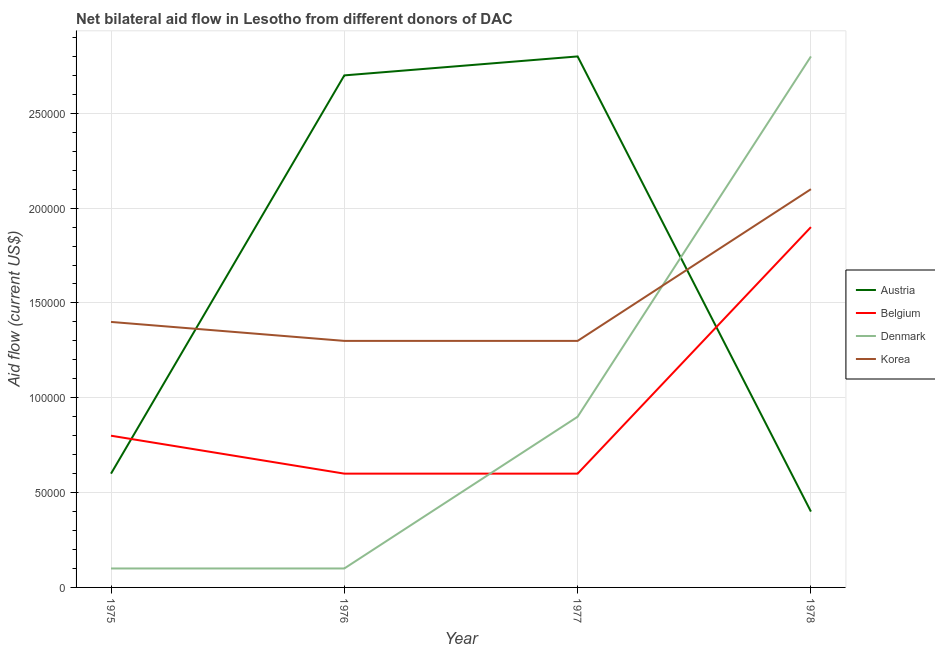How many different coloured lines are there?
Your answer should be very brief. 4. Is the number of lines equal to the number of legend labels?
Your answer should be compact. Yes. What is the amount of aid given by austria in 1975?
Provide a short and direct response. 6.00e+04. Across all years, what is the maximum amount of aid given by belgium?
Your answer should be compact. 1.90e+05. Across all years, what is the minimum amount of aid given by austria?
Provide a succinct answer. 4.00e+04. In which year was the amount of aid given by austria maximum?
Offer a very short reply. 1977. In which year was the amount of aid given by denmark minimum?
Make the answer very short. 1975. What is the total amount of aid given by austria in the graph?
Ensure brevity in your answer.  6.50e+05. What is the difference between the amount of aid given by korea in 1975 and that in 1978?
Your answer should be very brief. -7.00e+04. What is the difference between the amount of aid given by belgium in 1977 and the amount of aid given by denmark in 1976?
Provide a short and direct response. 5.00e+04. What is the average amount of aid given by korea per year?
Offer a terse response. 1.52e+05. In the year 1978, what is the difference between the amount of aid given by denmark and amount of aid given by belgium?
Make the answer very short. 9.00e+04. In how many years, is the amount of aid given by korea greater than 280000 US$?
Make the answer very short. 0. What is the ratio of the amount of aid given by korea in 1975 to that in 1976?
Your answer should be compact. 1.08. Is the amount of aid given by austria in 1976 less than that in 1977?
Provide a short and direct response. Yes. Is the difference between the amount of aid given by belgium in 1975 and 1976 greater than the difference between the amount of aid given by korea in 1975 and 1976?
Your answer should be very brief. Yes. What is the difference between the highest and the lowest amount of aid given by belgium?
Provide a succinct answer. 1.30e+05. In how many years, is the amount of aid given by denmark greater than the average amount of aid given by denmark taken over all years?
Your answer should be compact. 1. Is it the case that in every year, the sum of the amount of aid given by denmark and amount of aid given by austria is greater than the sum of amount of aid given by korea and amount of aid given by belgium?
Give a very brief answer. No. Is it the case that in every year, the sum of the amount of aid given by austria and amount of aid given by belgium is greater than the amount of aid given by denmark?
Your response must be concise. No. Does the amount of aid given by denmark monotonically increase over the years?
Provide a succinct answer. No. Is the amount of aid given by austria strictly less than the amount of aid given by korea over the years?
Make the answer very short. No. How many lines are there?
Give a very brief answer. 4. What is the difference between two consecutive major ticks on the Y-axis?
Your answer should be very brief. 5.00e+04. Does the graph contain any zero values?
Your response must be concise. No. Does the graph contain grids?
Ensure brevity in your answer.  Yes. How many legend labels are there?
Provide a short and direct response. 4. What is the title of the graph?
Your answer should be compact. Net bilateral aid flow in Lesotho from different donors of DAC. Does "Other Minerals" appear as one of the legend labels in the graph?
Your answer should be very brief. No. What is the label or title of the Y-axis?
Give a very brief answer. Aid flow (current US$). What is the Aid flow (current US$) of Denmark in 1975?
Your answer should be compact. 10000. What is the Aid flow (current US$) in Korea in 1976?
Provide a succinct answer. 1.30e+05. What is the Aid flow (current US$) in Austria in 1977?
Provide a short and direct response. 2.80e+05. What is the Aid flow (current US$) in Belgium in 1977?
Keep it short and to the point. 6.00e+04. What is the Aid flow (current US$) in Denmark in 1978?
Offer a very short reply. 2.80e+05. Across all years, what is the maximum Aid flow (current US$) in Korea?
Make the answer very short. 2.10e+05. Across all years, what is the minimum Aid flow (current US$) of Austria?
Offer a very short reply. 4.00e+04. Across all years, what is the minimum Aid flow (current US$) of Denmark?
Give a very brief answer. 10000. What is the total Aid flow (current US$) in Austria in the graph?
Your response must be concise. 6.50e+05. What is the total Aid flow (current US$) of Denmark in the graph?
Offer a terse response. 3.90e+05. What is the total Aid flow (current US$) of Korea in the graph?
Your answer should be very brief. 6.10e+05. What is the difference between the Aid flow (current US$) in Austria in 1975 and that in 1976?
Provide a short and direct response. -2.10e+05. What is the difference between the Aid flow (current US$) of Denmark in 1975 and that in 1976?
Your response must be concise. 0. What is the difference between the Aid flow (current US$) in Korea in 1975 and that in 1977?
Offer a terse response. 10000. What is the difference between the Aid flow (current US$) in Korea in 1975 and that in 1978?
Your answer should be compact. -7.00e+04. What is the difference between the Aid flow (current US$) of Austria in 1976 and that in 1977?
Offer a terse response. -10000. What is the difference between the Aid flow (current US$) in Korea in 1976 and that in 1977?
Your response must be concise. 0. What is the difference between the Aid flow (current US$) in Denmark in 1976 and that in 1978?
Your response must be concise. -2.70e+05. What is the difference between the Aid flow (current US$) in Korea in 1976 and that in 1978?
Ensure brevity in your answer.  -8.00e+04. What is the difference between the Aid flow (current US$) in Belgium in 1977 and that in 1978?
Ensure brevity in your answer.  -1.30e+05. What is the difference between the Aid flow (current US$) in Austria in 1975 and the Aid flow (current US$) in Korea in 1976?
Your answer should be compact. -7.00e+04. What is the difference between the Aid flow (current US$) in Belgium in 1975 and the Aid flow (current US$) in Denmark in 1976?
Give a very brief answer. 7.00e+04. What is the difference between the Aid flow (current US$) of Belgium in 1975 and the Aid flow (current US$) of Korea in 1976?
Give a very brief answer. -5.00e+04. What is the difference between the Aid flow (current US$) in Belgium in 1975 and the Aid flow (current US$) in Korea in 1977?
Make the answer very short. -5.00e+04. What is the difference between the Aid flow (current US$) in Austria in 1975 and the Aid flow (current US$) in Belgium in 1978?
Ensure brevity in your answer.  -1.30e+05. What is the difference between the Aid flow (current US$) in Austria in 1975 and the Aid flow (current US$) in Denmark in 1978?
Offer a very short reply. -2.20e+05. What is the difference between the Aid flow (current US$) of Austria in 1976 and the Aid flow (current US$) of Belgium in 1977?
Your response must be concise. 2.10e+05. What is the difference between the Aid flow (current US$) of Austria in 1976 and the Aid flow (current US$) of Denmark in 1977?
Make the answer very short. 1.80e+05. What is the difference between the Aid flow (current US$) of Austria in 1976 and the Aid flow (current US$) of Korea in 1977?
Your answer should be very brief. 1.40e+05. What is the difference between the Aid flow (current US$) of Belgium in 1976 and the Aid flow (current US$) of Denmark in 1977?
Provide a succinct answer. -3.00e+04. What is the difference between the Aid flow (current US$) in Belgium in 1976 and the Aid flow (current US$) in Korea in 1977?
Your answer should be compact. -7.00e+04. What is the difference between the Aid flow (current US$) in Denmark in 1976 and the Aid flow (current US$) in Korea in 1977?
Your answer should be very brief. -1.20e+05. What is the difference between the Aid flow (current US$) in Austria in 1976 and the Aid flow (current US$) in Denmark in 1978?
Make the answer very short. -10000. What is the difference between the Aid flow (current US$) of Austria in 1976 and the Aid flow (current US$) of Korea in 1978?
Your answer should be very brief. 6.00e+04. What is the difference between the Aid flow (current US$) of Belgium in 1976 and the Aid flow (current US$) of Denmark in 1978?
Give a very brief answer. -2.20e+05. What is the difference between the Aid flow (current US$) in Denmark in 1976 and the Aid flow (current US$) in Korea in 1978?
Ensure brevity in your answer.  -2.00e+05. What is the difference between the Aid flow (current US$) of Austria in 1977 and the Aid flow (current US$) of Belgium in 1978?
Your response must be concise. 9.00e+04. What is the difference between the Aid flow (current US$) in Austria in 1977 and the Aid flow (current US$) in Denmark in 1978?
Your response must be concise. 0. What is the difference between the Aid flow (current US$) in Austria in 1977 and the Aid flow (current US$) in Korea in 1978?
Keep it short and to the point. 7.00e+04. What is the difference between the Aid flow (current US$) of Belgium in 1977 and the Aid flow (current US$) of Korea in 1978?
Your answer should be compact. -1.50e+05. What is the difference between the Aid flow (current US$) in Denmark in 1977 and the Aid flow (current US$) in Korea in 1978?
Your response must be concise. -1.20e+05. What is the average Aid flow (current US$) in Austria per year?
Offer a terse response. 1.62e+05. What is the average Aid flow (current US$) in Belgium per year?
Ensure brevity in your answer.  9.75e+04. What is the average Aid flow (current US$) of Denmark per year?
Your answer should be very brief. 9.75e+04. What is the average Aid flow (current US$) in Korea per year?
Your answer should be compact. 1.52e+05. In the year 1975, what is the difference between the Aid flow (current US$) of Austria and Aid flow (current US$) of Belgium?
Make the answer very short. -2.00e+04. In the year 1975, what is the difference between the Aid flow (current US$) in Austria and Aid flow (current US$) in Korea?
Provide a short and direct response. -8.00e+04. In the year 1975, what is the difference between the Aid flow (current US$) in Belgium and Aid flow (current US$) in Denmark?
Give a very brief answer. 7.00e+04. In the year 1975, what is the difference between the Aid flow (current US$) of Belgium and Aid flow (current US$) of Korea?
Your response must be concise. -6.00e+04. In the year 1976, what is the difference between the Aid flow (current US$) in Austria and Aid flow (current US$) in Belgium?
Offer a terse response. 2.10e+05. In the year 1976, what is the difference between the Aid flow (current US$) in Belgium and Aid flow (current US$) in Denmark?
Provide a short and direct response. 5.00e+04. In the year 1976, what is the difference between the Aid flow (current US$) of Denmark and Aid flow (current US$) of Korea?
Provide a succinct answer. -1.20e+05. In the year 1977, what is the difference between the Aid flow (current US$) in Austria and Aid flow (current US$) in Belgium?
Offer a very short reply. 2.20e+05. In the year 1977, what is the difference between the Aid flow (current US$) of Austria and Aid flow (current US$) of Korea?
Your response must be concise. 1.50e+05. In the year 1977, what is the difference between the Aid flow (current US$) of Belgium and Aid flow (current US$) of Denmark?
Your answer should be very brief. -3.00e+04. In the year 1978, what is the difference between the Aid flow (current US$) in Austria and Aid flow (current US$) in Denmark?
Offer a terse response. -2.40e+05. In the year 1978, what is the difference between the Aid flow (current US$) in Austria and Aid flow (current US$) in Korea?
Provide a succinct answer. -1.70e+05. In the year 1978, what is the difference between the Aid flow (current US$) in Belgium and Aid flow (current US$) in Denmark?
Your answer should be compact. -9.00e+04. What is the ratio of the Aid flow (current US$) in Austria in 1975 to that in 1976?
Offer a very short reply. 0.22. What is the ratio of the Aid flow (current US$) of Austria in 1975 to that in 1977?
Provide a short and direct response. 0.21. What is the ratio of the Aid flow (current US$) in Denmark in 1975 to that in 1977?
Give a very brief answer. 0.11. What is the ratio of the Aid flow (current US$) of Korea in 1975 to that in 1977?
Make the answer very short. 1.08. What is the ratio of the Aid flow (current US$) in Belgium in 1975 to that in 1978?
Provide a succinct answer. 0.42. What is the ratio of the Aid flow (current US$) of Denmark in 1975 to that in 1978?
Offer a very short reply. 0.04. What is the ratio of the Aid flow (current US$) of Denmark in 1976 to that in 1977?
Provide a succinct answer. 0.11. What is the ratio of the Aid flow (current US$) of Korea in 1976 to that in 1977?
Offer a terse response. 1. What is the ratio of the Aid flow (current US$) of Austria in 1976 to that in 1978?
Provide a short and direct response. 6.75. What is the ratio of the Aid flow (current US$) in Belgium in 1976 to that in 1978?
Provide a short and direct response. 0.32. What is the ratio of the Aid flow (current US$) in Denmark in 1976 to that in 1978?
Your answer should be compact. 0.04. What is the ratio of the Aid flow (current US$) in Korea in 1976 to that in 1978?
Your answer should be compact. 0.62. What is the ratio of the Aid flow (current US$) of Austria in 1977 to that in 1978?
Offer a very short reply. 7. What is the ratio of the Aid flow (current US$) in Belgium in 1977 to that in 1978?
Your answer should be compact. 0.32. What is the ratio of the Aid flow (current US$) of Denmark in 1977 to that in 1978?
Give a very brief answer. 0.32. What is the ratio of the Aid flow (current US$) of Korea in 1977 to that in 1978?
Ensure brevity in your answer.  0.62. What is the difference between the highest and the second highest Aid flow (current US$) in Austria?
Give a very brief answer. 10000. What is the difference between the highest and the second highest Aid flow (current US$) of Belgium?
Your answer should be compact. 1.10e+05. What is the difference between the highest and the lowest Aid flow (current US$) in Austria?
Your answer should be very brief. 2.40e+05. What is the difference between the highest and the lowest Aid flow (current US$) in Korea?
Make the answer very short. 8.00e+04. 